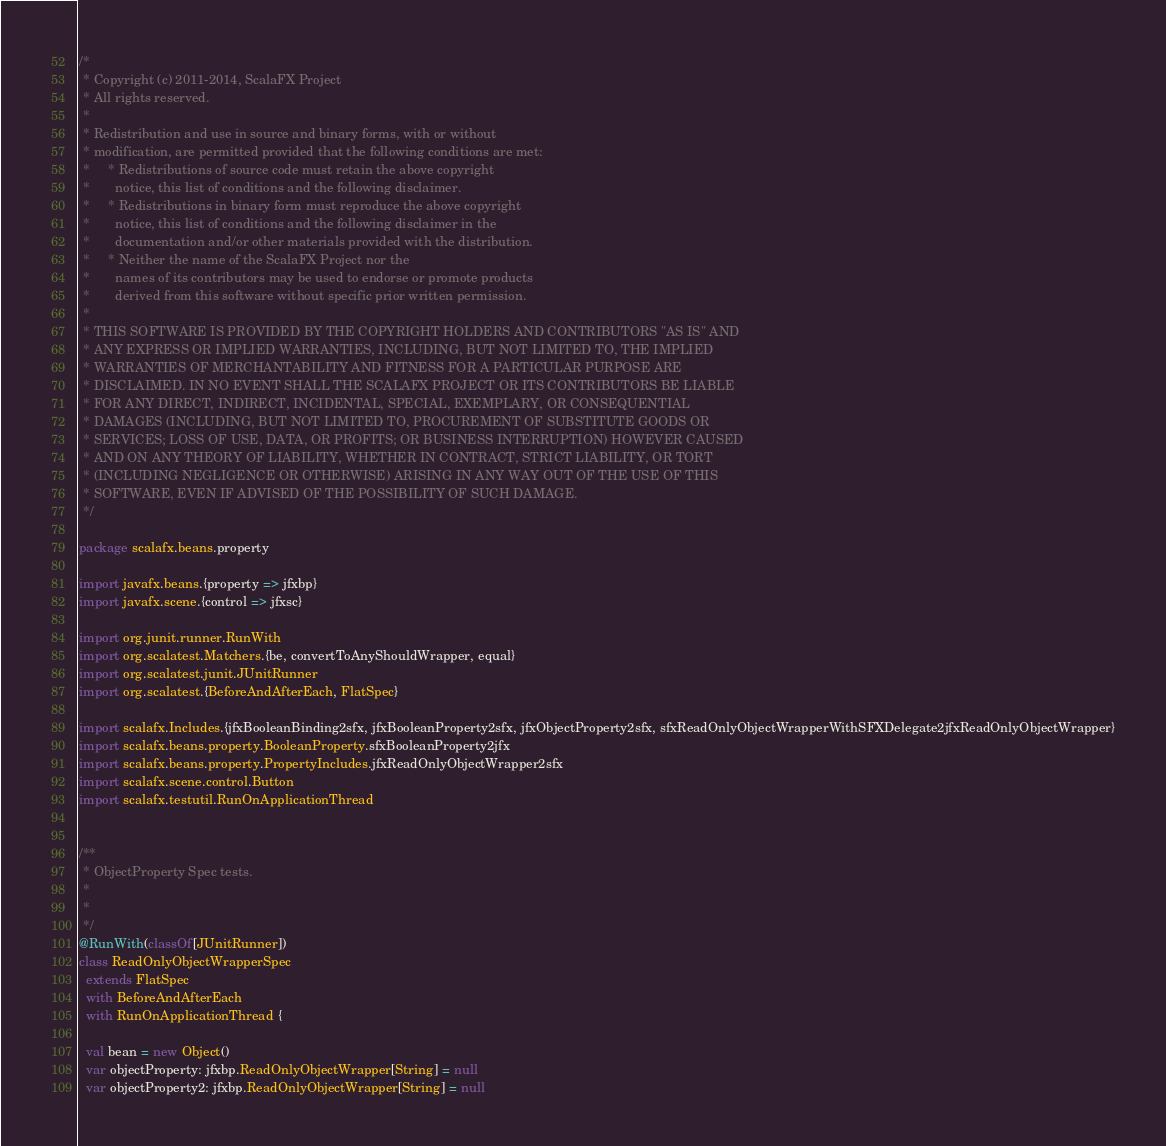Convert code to text. <code><loc_0><loc_0><loc_500><loc_500><_Scala_>/*
 * Copyright (c) 2011-2014, ScalaFX Project
 * All rights reserved.
 *
 * Redistribution and use in source and binary forms, with or without
 * modification, are permitted provided that the following conditions are met:
 *     * Redistributions of source code must retain the above copyright
 *       notice, this list of conditions and the following disclaimer.
 *     * Redistributions in binary form must reproduce the above copyright
 *       notice, this list of conditions and the following disclaimer in the
 *       documentation and/or other materials provided with the distribution.
 *     * Neither the name of the ScalaFX Project nor the
 *       names of its contributors may be used to endorse or promote products
 *       derived from this software without specific prior written permission.
 *
 * THIS SOFTWARE IS PROVIDED BY THE COPYRIGHT HOLDERS AND CONTRIBUTORS "AS IS" AND
 * ANY EXPRESS OR IMPLIED WARRANTIES, INCLUDING, BUT NOT LIMITED TO, THE IMPLIED
 * WARRANTIES OF MERCHANTABILITY AND FITNESS FOR A PARTICULAR PURPOSE ARE
 * DISCLAIMED. IN NO EVENT SHALL THE SCALAFX PROJECT OR ITS CONTRIBUTORS BE LIABLE
 * FOR ANY DIRECT, INDIRECT, INCIDENTAL, SPECIAL, EXEMPLARY, OR CONSEQUENTIAL
 * DAMAGES (INCLUDING, BUT NOT LIMITED TO, PROCUREMENT OF SUBSTITUTE GOODS OR
 * SERVICES; LOSS OF USE, DATA, OR PROFITS; OR BUSINESS INTERRUPTION) HOWEVER CAUSED
 * AND ON ANY THEORY OF LIABILITY, WHETHER IN CONTRACT, STRICT LIABILITY, OR TORT
 * (INCLUDING NEGLIGENCE OR OTHERWISE) ARISING IN ANY WAY OUT OF THE USE OF THIS
 * SOFTWARE, EVEN IF ADVISED OF THE POSSIBILITY OF SUCH DAMAGE.
 */

package scalafx.beans.property

import javafx.beans.{property => jfxbp}
import javafx.scene.{control => jfxsc}

import org.junit.runner.RunWith
import org.scalatest.Matchers.{be, convertToAnyShouldWrapper, equal}
import org.scalatest.junit.JUnitRunner
import org.scalatest.{BeforeAndAfterEach, FlatSpec}

import scalafx.Includes.{jfxBooleanBinding2sfx, jfxBooleanProperty2sfx, jfxObjectProperty2sfx, sfxReadOnlyObjectWrapperWithSFXDelegate2jfxReadOnlyObjectWrapper}
import scalafx.beans.property.BooleanProperty.sfxBooleanProperty2jfx
import scalafx.beans.property.PropertyIncludes.jfxReadOnlyObjectWrapper2sfx
import scalafx.scene.control.Button
import scalafx.testutil.RunOnApplicationThread


/**
 * ObjectProperty Spec tests.
 *
 *
 */
@RunWith(classOf[JUnitRunner])
class ReadOnlyObjectWrapperSpec
  extends FlatSpec
  with BeforeAndAfterEach
  with RunOnApplicationThread {

  val bean = new Object()
  var objectProperty: jfxbp.ReadOnlyObjectWrapper[String] = null
  var objectProperty2: jfxbp.ReadOnlyObjectWrapper[String] = null</code> 